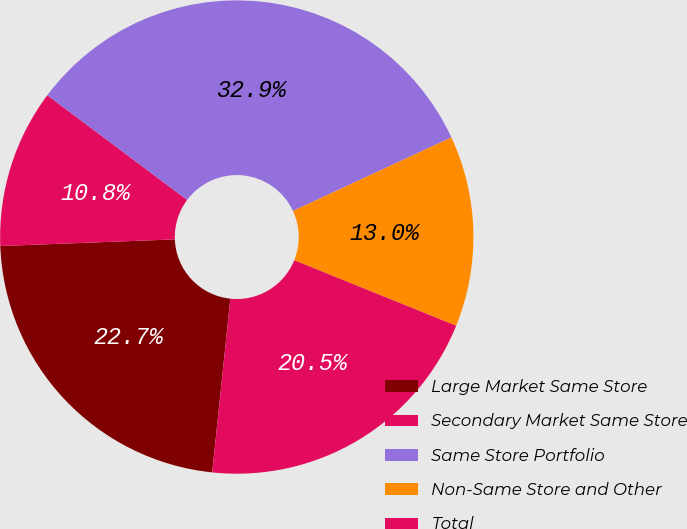Convert chart. <chart><loc_0><loc_0><loc_500><loc_500><pie_chart><fcel>Large Market Same Store<fcel>Secondary Market Same Store<fcel>Same Store Portfolio<fcel>Non-Same Store and Other<fcel>Total<nl><fcel>22.74%<fcel>10.83%<fcel>32.86%<fcel>13.03%<fcel>20.54%<nl></chart> 